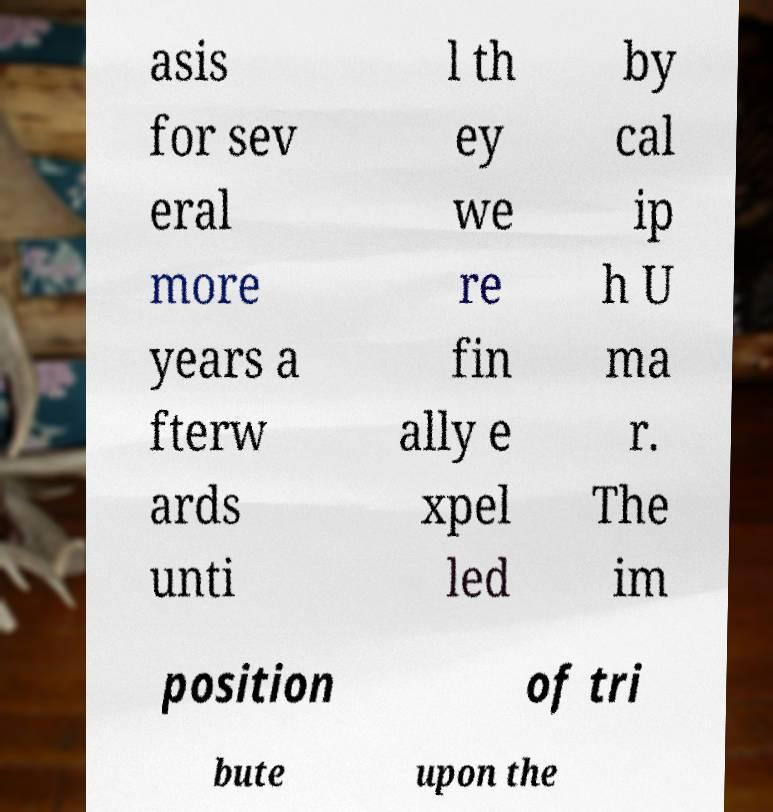Could you assist in decoding the text presented in this image and type it out clearly? asis for sev eral more years a fterw ards unti l th ey we re fin ally e xpel led by cal ip h U ma r. The im position of tri bute upon the 